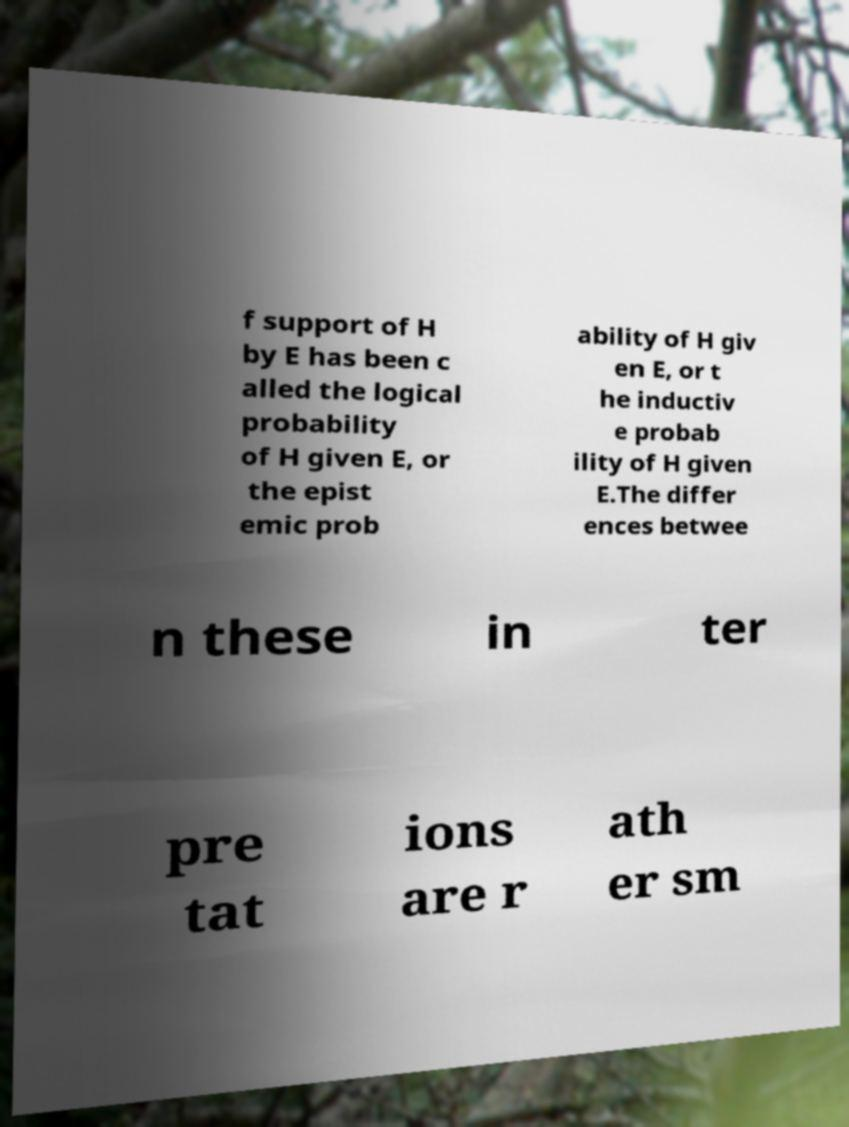Can you accurately transcribe the text from the provided image for me? f support of H by E has been c alled the logical probability of H given E, or the epist emic prob ability of H giv en E, or t he inductiv e probab ility of H given E.The differ ences betwee n these in ter pre tat ions are r ath er sm 